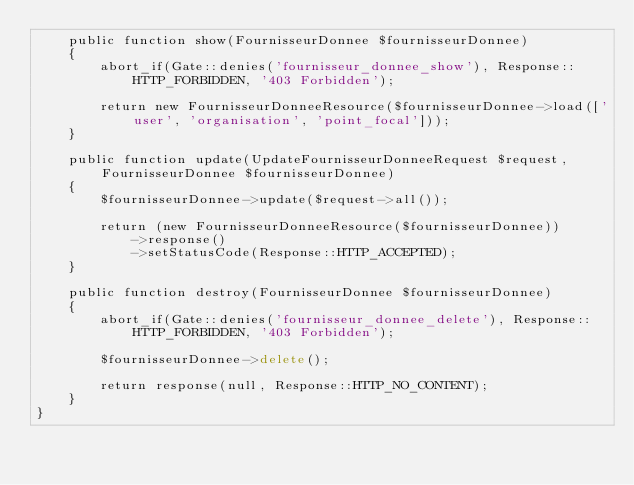<code> <loc_0><loc_0><loc_500><loc_500><_PHP_>    public function show(FournisseurDonnee $fournisseurDonnee)
    {
        abort_if(Gate::denies('fournisseur_donnee_show'), Response::HTTP_FORBIDDEN, '403 Forbidden');

        return new FournisseurDonneeResource($fournisseurDonnee->load(['user', 'organisation', 'point_focal']));
    }

    public function update(UpdateFournisseurDonneeRequest $request, FournisseurDonnee $fournisseurDonnee)
    {
        $fournisseurDonnee->update($request->all());

        return (new FournisseurDonneeResource($fournisseurDonnee))
            ->response()
            ->setStatusCode(Response::HTTP_ACCEPTED);
    }

    public function destroy(FournisseurDonnee $fournisseurDonnee)
    {
        abort_if(Gate::denies('fournisseur_donnee_delete'), Response::HTTP_FORBIDDEN, '403 Forbidden');

        $fournisseurDonnee->delete();

        return response(null, Response::HTTP_NO_CONTENT);
    }
}
</code> 